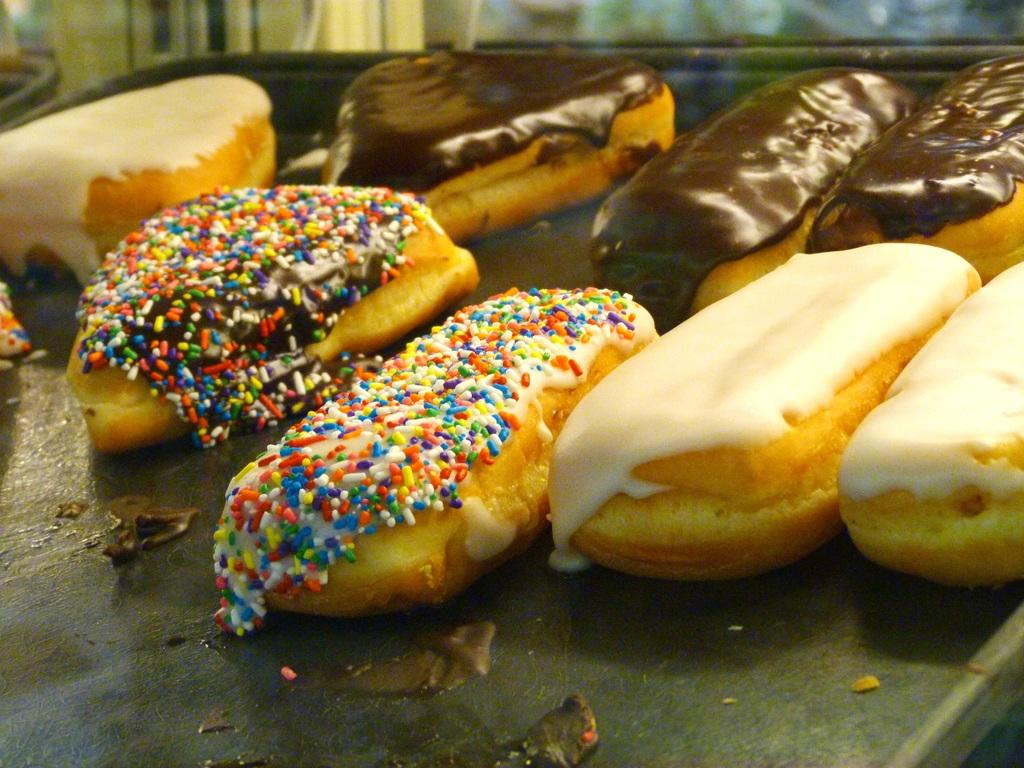What is located in the center of the image? There is a table in the center of the image. What can be seen on the table? Cakes are present on the table. What type of pear is being used as a decoration on the table? There is no pear present in the image; only cakes are visible on the table. 